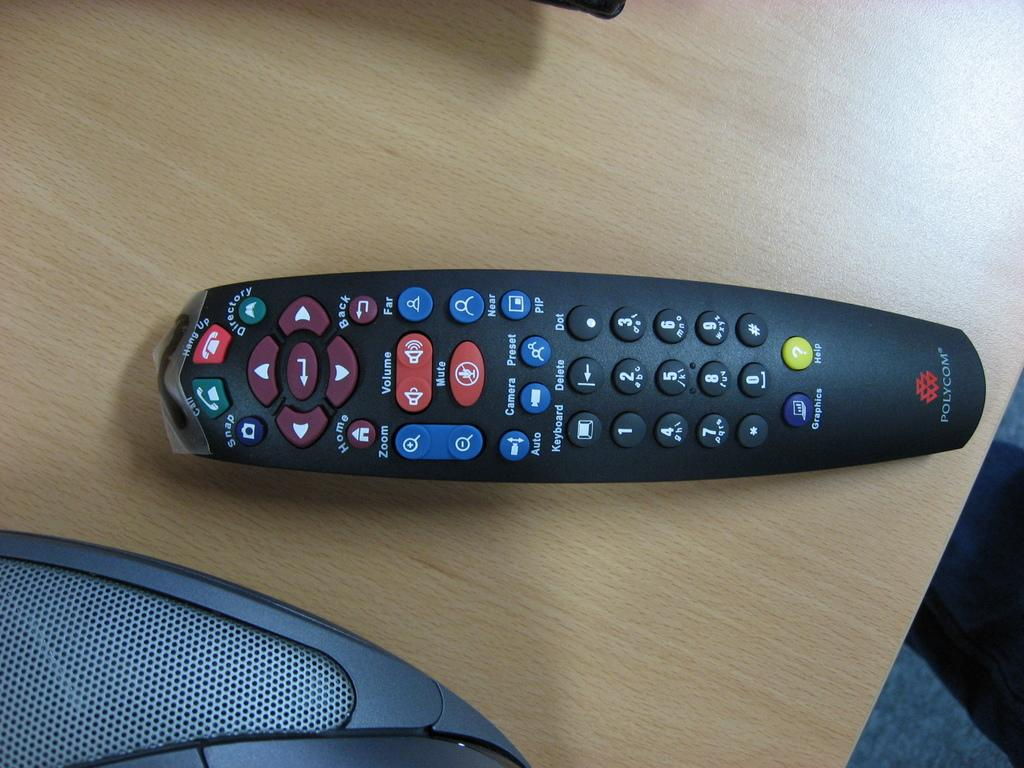Provide a one-sentence caption for the provided image. The TV remote on the table was made by a company Polycom. 